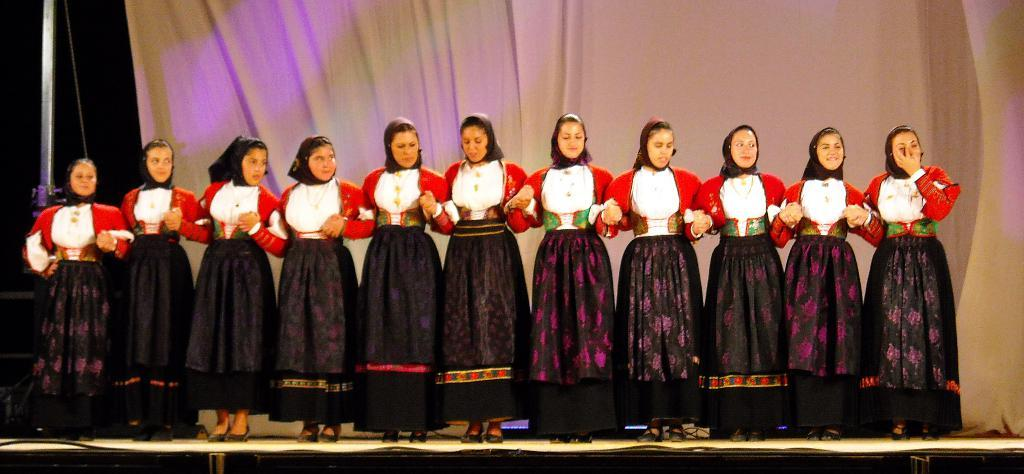What are the people in the image doing? The people in the image are standing and smiling. What can be seen in the background of the image? There is a curtain visible in the image. What object is present in the image that might be used for support or decoration? There is a pole in the image. What type of basketball skills are the people demonstrating in the image? There is no basketball present in the image, so no such skills can be observed. What type of skirt is the person wearing in the image? There is no person wearing a skirt in the image. What is the person doing with their thumb in the image? There is no person using their thumb in a specific way in the image. 